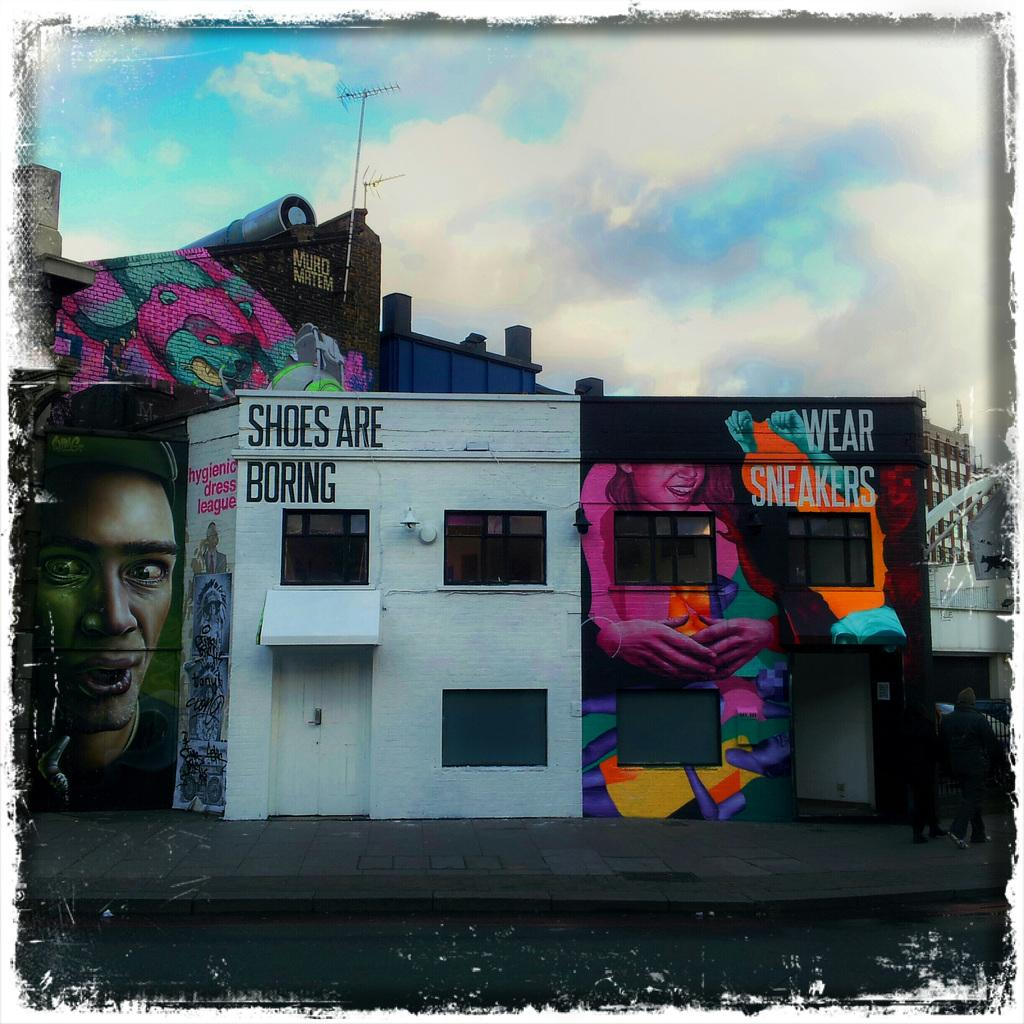What type of structure is visible in the image? There is a building in the image. What can be found inside the building? The building contains art. What is visible in the sky in the image? There are clouds in the sky. What is located at the bottom of the image? There is a footpath at the bottom of the image. What type of power is being generated by the minister in the image? There is no minister present in the image, and therefore no power generation can be observed. Can you tell me how many volleyballs are visible in the image? There are no volleyballs present in the image. 